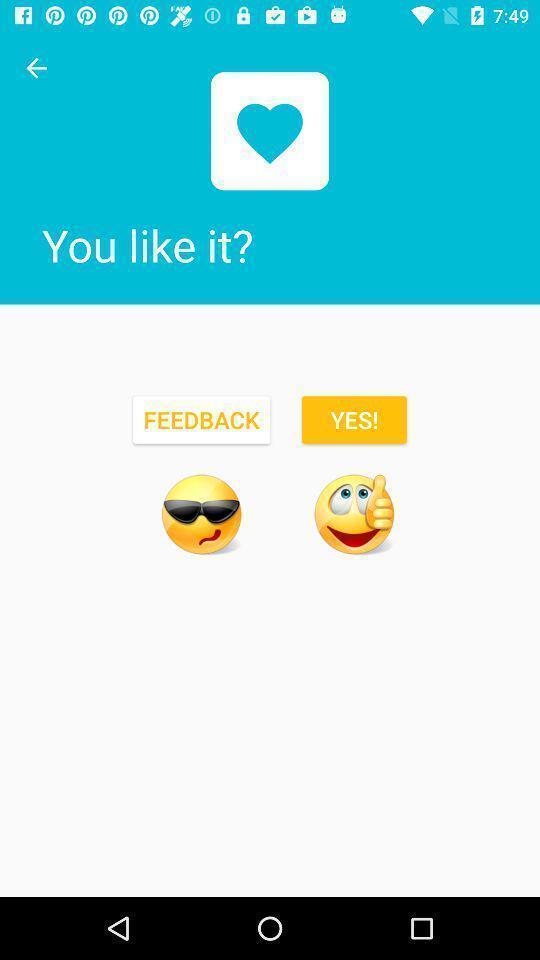Provide a description of this screenshot. Screen showing feedback page. 